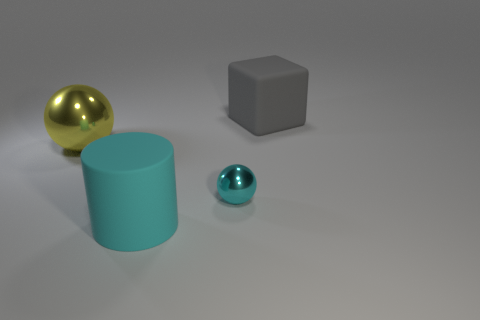Are there more big blue metal things than matte cylinders?
Provide a succinct answer. No. There is a cyan object in front of the metallic thing that is in front of the big yellow thing; how big is it?
Give a very brief answer. Large. The tiny thing that is the same shape as the large yellow thing is what color?
Make the answer very short. Cyan. How big is the gray object?
Give a very brief answer. Large. What number of balls are either large cyan things or yellow objects?
Your response must be concise. 1. There is a cyan shiny thing that is the same shape as the yellow metallic thing; what size is it?
Offer a terse response. Small. What number of yellow metal balls are there?
Keep it short and to the point. 1. There is a small cyan metallic object; is it the same shape as the matte object to the right of the small sphere?
Give a very brief answer. No. There is a shiny thing that is right of the matte cylinder; what size is it?
Provide a short and direct response. Small. What material is the big cylinder?
Provide a short and direct response. Rubber. 